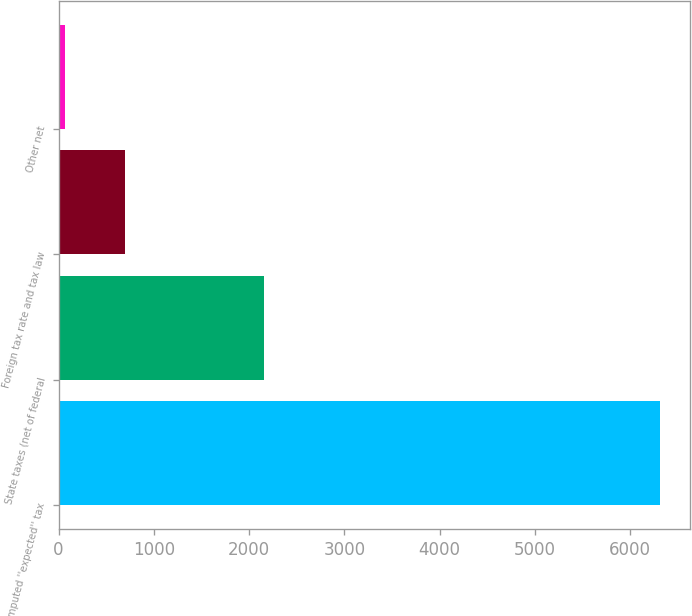Convert chart. <chart><loc_0><loc_0><loc_500><loc_500><bar_chart><fcel>Computed ''expected'' tax<fcel>State taxes (net of federal<fcel>Foreign tax rate and tax law<fcel>Other net<nl><fcel>6311<fcel>2157<fcel>694.1<fcel>70<nl></chart> 